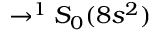<formula> <loc_0><loc_0><loc_500><loc_500>\rightarrow ^ { 1 } S _ { 0 } ( 8 s ^ { 2 } )</formula> 